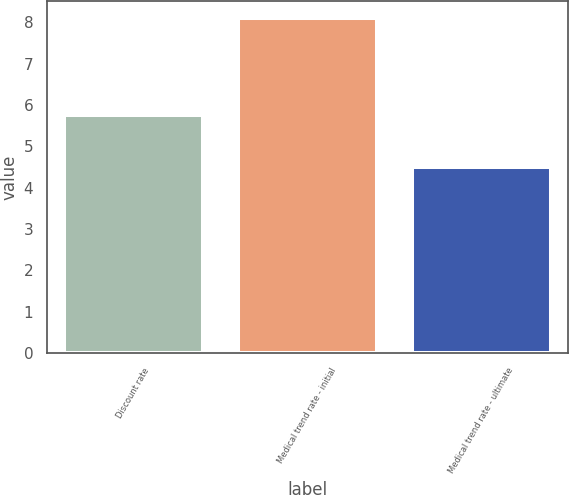Convert chart. <chart><loc_0><loc_0><loc_500><loc_500><bar_chart><fcel>Discount rate<fcel>Medical trend rate - initial<fcel>Medical trend rate - ultimate<nl><fcel>5.75<fcel>8.1<fcel>4.5<nl></chart> 